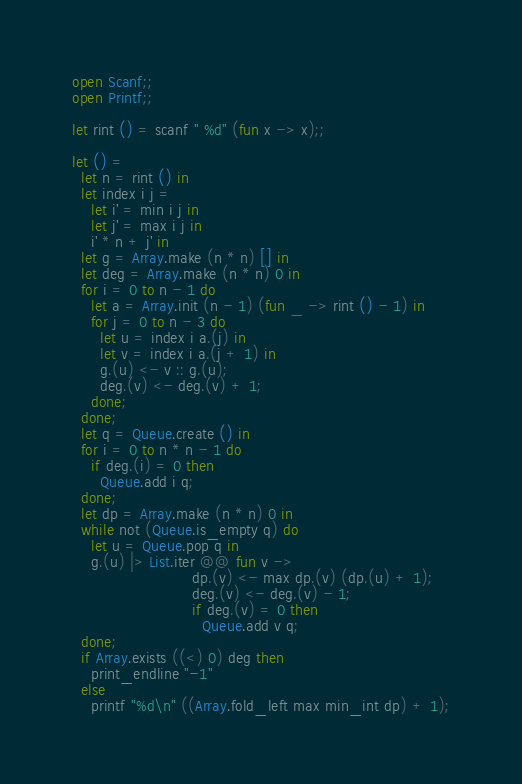<code> <loc_0><loc_0><loc_500><loc_500><_OCaml_>open Scanf;;
open Printf;;

let rint () = scanf " %d" (fun x -> x);;

let () =
  let n = rint () in
  let index i j =
    let i' = min i j in
    let j' = max i j in
    i' * n + j' in
  let g = Array.make (n * n) [] in
  let deg = Array.make (n * n) 0 in
  for i = 0 to n - 1 do
    let a = Array.init (n - 1) (fun _ -> rint () - 1) in
    for j = 0 to n - 3 do
      let u = index i a.(j) in
      let v = index i a.(j + 1) in
      g.(u) <- v :: g.(u);
      deg.(v) <- deg.(v) + 1;
    done;
  done;
  let q = Queue.create () in
  for i = 0 to n * n - 1 do
    if deg.(i) = 0 then
      Queue.add i q;
  done;
  let dp = Array.make (n * n) 0 in
  while not (Queue.is_empty q) do
    let u = Queue.pop q in
    g.(u) |> List.iter @@ fun v ->
                          dp.(v) <- max dp.(v) (dp.(u) + 1);
                          deg.(v) <- deg.(v) - 1;
                          if deg.(v) = 0 then
                            Queue.add v q;
  done;
  if Array.exists ((<) 0) deg then
    print_endline "-1"
  else
    printf "%d\n" ((Array.fold_left max min_int dp) + 1);
</code> 